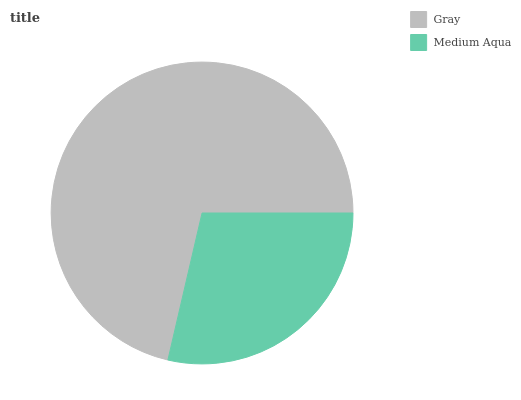Is Medium Aqua the minimum?
Answer yes or no. Yes. Is Gray the maximum?
Answer yes or no. Yes. Is Medium Aqua the maximum?
Answer yes or no. No. Is Gray greater than Medium Aqua?
Answer yes or no. Yes. Is Medium Aqua less than Gray?
Answer yes or no. Yes. Is Medium Aqua greater than Gray?
Answer yes or no. No. Is Gray less than Medium Aqua?
Answer yes or no. No. Is Gray the high median?
Answer yes or no. Yes. Is Medium Aqua the low median?
Answer yes or no. Yes. Is Medium Aqua the high median?
Answer yes or no. No. Is Gray the low median?
Answer yes or no. No. 